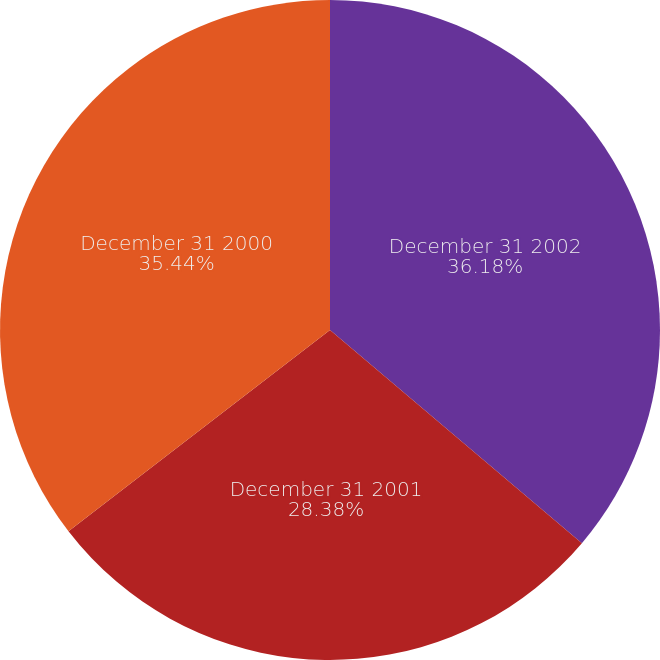<chart> <loc_0><loc_0><loc_500><loc_500><pie_chart><fcel>December 31 2002<fcel>December 31 2001<fcel>December 31 2000<nl><fcel>36.18%<fcel>28.38%<fcel>35.44%<nl></chart> 